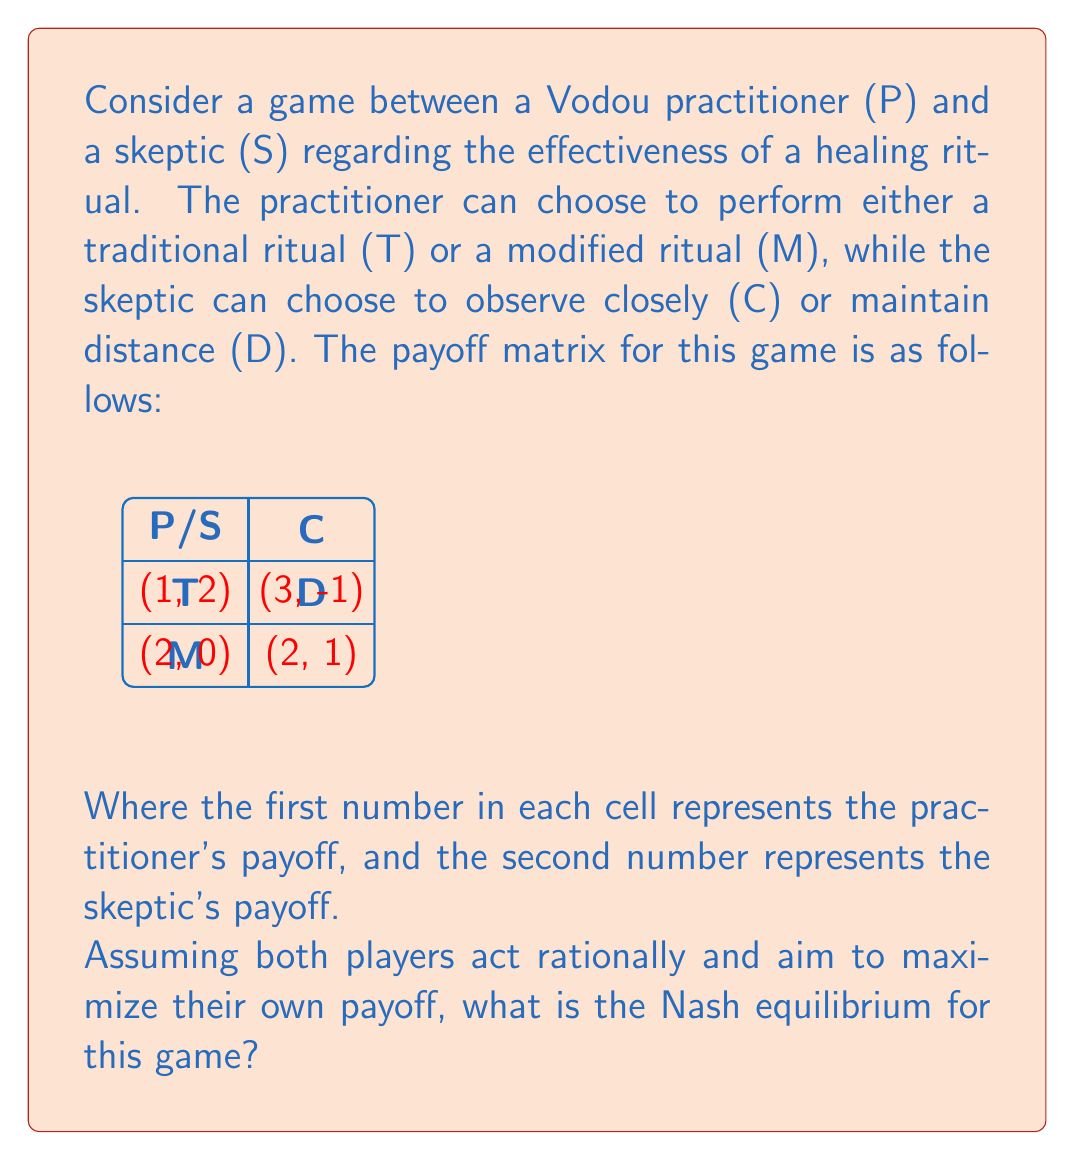Provide a solution to this math problem. To find the Nash equilibrium, we need to analyze each player's best response to the other player's strategy:

1. For the Vodou practitioner (P):
   - If S chooses C: P's best response is T (payoff 3 > 2)
   - If S chooses D: P's best response is M (payoff 2 > 1)

2. For the skeptic (S):
   - If P chooses T: S's best response is D (payoff 2 > -1)
   - If P chooses M: S's best response is C (payoff 1 > 0)

3. To find the Nash equilibrium, we look for a strategy combination where neither player has an incentive to unilaterally change their strategy:

   - (T, C) is not stable because S would switch to D
   - (T, D) is not stable because P would switch to M
   - (M, D) is not stable because S would switch to C
   - (M, C) is stable because:
     * P has no incentive to switch to T (2 > 1)
     * S has no incentive to switch to D (1 > 0)

4. Therefore, the Nash equilibrium is (M, C), where the practitioner performs a modified ritual and the skeptic observes closely.

This equilibrium represents a compromise between tradition and skepticism, where the practitioner adapts their practice to accommodate scrutiny, and the skeptic engages more closely with the ritual.
Answer: (M, C) 